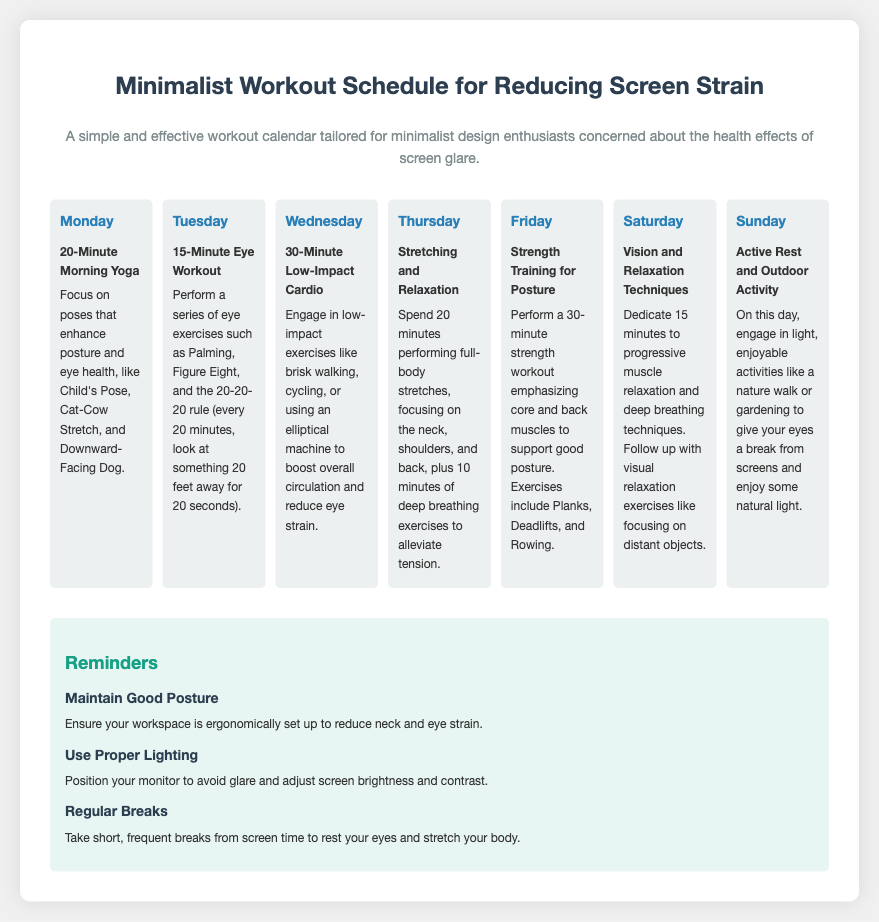What exercise is suggested for Monday? The exercise for Monday is a 20-Minute Morning Yoga session focusing on specific poses.
Answer: 20-Minute Morning Yoga How long is the eye workout on Tuesday? The document specifies that the eye workout on Tuesday is 15 minutes long.
Answer: 15-Minute What type of cardio is recommended on Wednesday? The document mentions engaging in low-impact cardio exercises on Wednesday.
Answer: Low-Impact Cardio Which day includes relaxation techniques? Thursday includes stretching and relaxation techniques.
Answer: Thursday How many minutes of outdoor activity are suggested for Sunday? The document suggests engaging in light outdoor activities without specifying a duration for Sunday.
Answer: Active Rest What reminder emphasizes workspace setup? The reminder that emphasizes workspace setup is titled "Maintain Good Posture."
Answer: Maintain Good Posture How many total exercises focus on stretching and relaxation? The document lists one workout focusing on stretching and relaxation techniques.
Answer: One What is the purpose of the workouts listed in the calendar? The workouts aim to reduce screen strain and improve eye health.
Answer: Reduce screen strain 